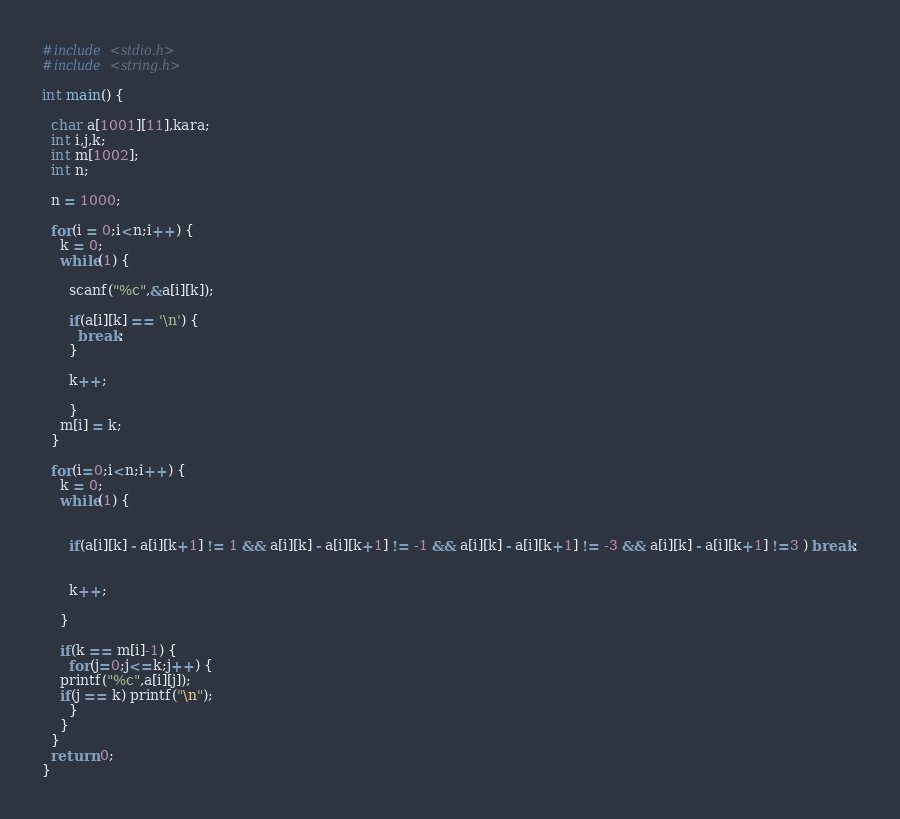<code> <loc_0><loc_0><loc_500><loc_500><_C_>#include <stdio.h>
#include <string.h>

int main() {

  char a[1001][11],kara;
  int i,j,k;
  int m[1002];
  int n;

  n = 1000;

  for(i = 0;i<n;i++) {
    k = 0;
    while(1) {

      scanf("%c",&a[i][k]);

	  if(a[i][k] == '\n') {
	    break;
	  }

	  k++;

	  }
    m[i] = k;
  }

  for(i=0;i<n;i++) {
    k = 0;
    while(1) {

      
      if(a[i][k] - a[i][k+1] != 1 && a[i][k] - a[i][k+1] != -1 && a[i][k] - a[i][k+1] != -3 && a[i][k] - a[i][k+1] !=3 ) break;
      

      k++;

    }

    if(k == m[i]-1) {
      for(j=0;j<=k;j++) {
	printf("%c",a[i][j]);
	if(j == k) printf("\n");
      }
    }
  }
  return 0;
}</code> 